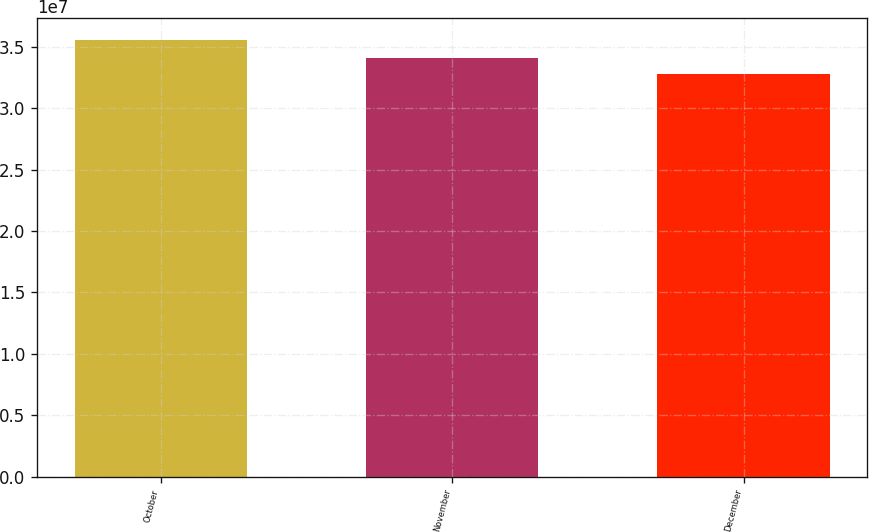Convert chart to OTSL. <chart><loc_0><loc_0><loc_500><loc_500><bar_chart><fcel>October<fcel>November<fcel>December<nl><fcel>3.55731e+07<fcel>3.40688e+07<fcel>3.27429e+07<nl></chart> 